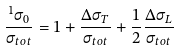Convert formula to latex. <formula><loc_0><loc_0><loc_500><loc_500>\frac { ^ { 1 } \sigma _ { 0 } } { \sigma _ { t o t } } = 1 + \frac { \Delta \sigma _ { T } } { \sigma _ { t o t } } + \frac { 1 } { 2 } \frac { \Delta \sigma _ { L } } { \sigma _ { t o t } }</formula> 